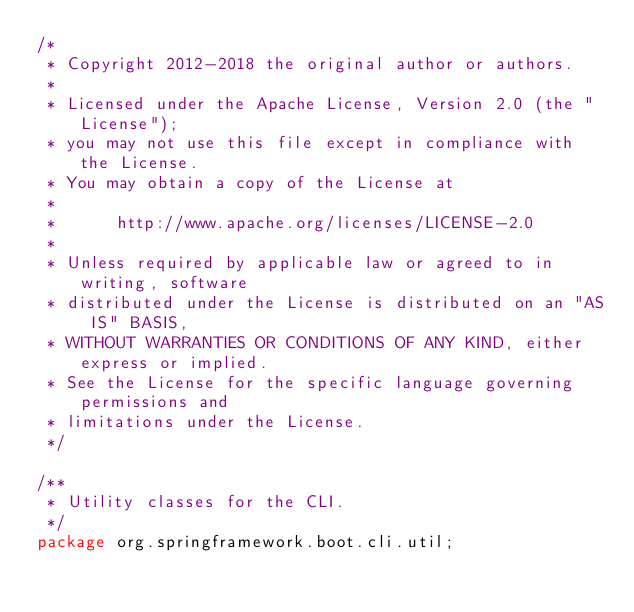Convert code to text. <code><loc_0><loc_0><loc_500><loc_500><_Java_>/*
 * Copyright 2012-2018 the original author or authors.
 *
 * Licensed under the Apache License, Version 2.0 (the "License");
 * you may not use this file except in compliance with the License.
 * You may obtain a copy of the License at
 *
 *      http://www.apache.org/licenses/LICENSE-2.0
 *
 * Unless required by applicable law or agreed to in writing, software
 * distributed under the License is distributed on an "AS IS" BASIS,
 * WITHOUT WARRANTIES OR CONDITIONS OF ANY KIND, either express or implied.
 * See the License for the specific language governing permissions and
 * limitations under the License.
 */

/**
 * Utility classes for the CLI.
 */
package org.springframework.boot.cli.util;
</code> 